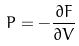<formula> <loc_0><loc_0><loc_500><loc_500>P = - \frac { \partial F } { \partial V }</formula> 